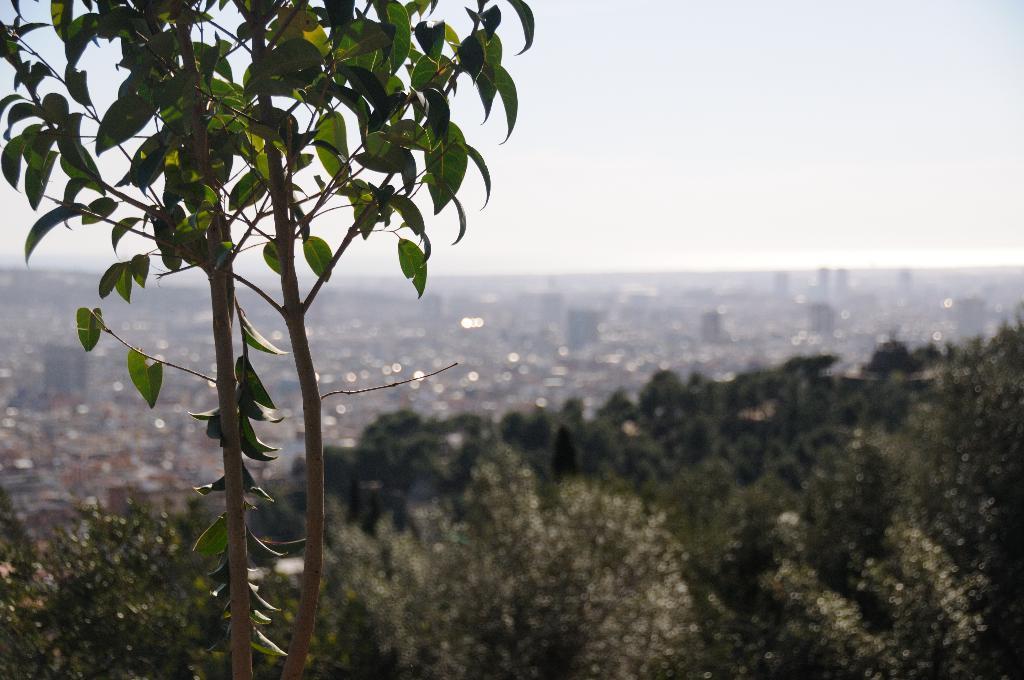Can you describe this image briefly? In this image, I can see the trees and there are buildings, which are blurred. In the background, there is the sky. 